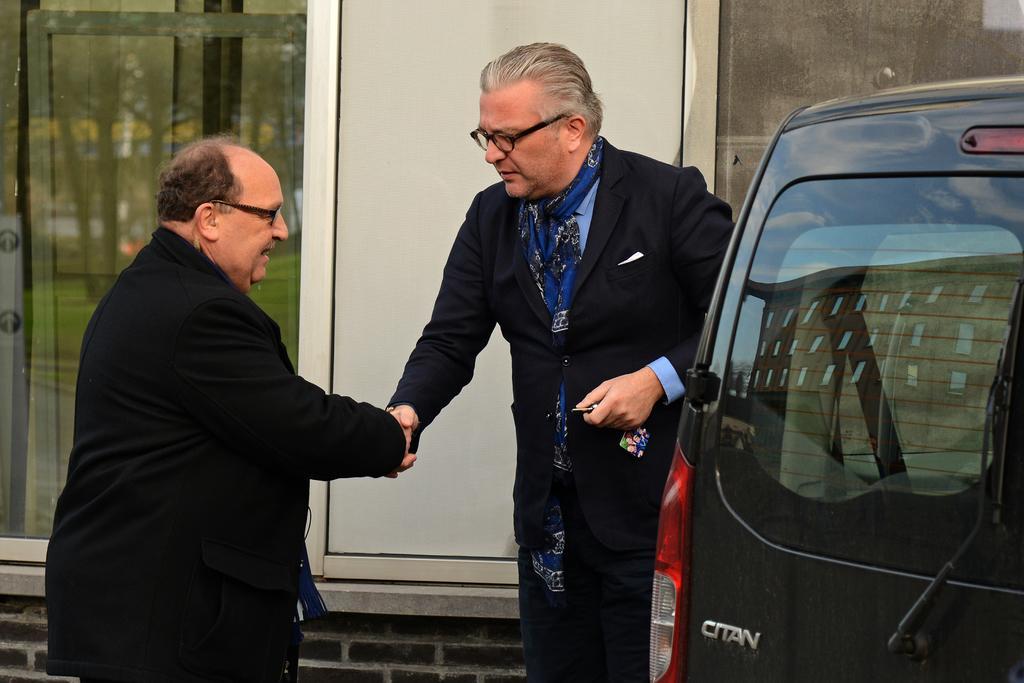Could you give a brief overview of what you see in this image? In this image we can see two people shaking their hands. We can also see a car beside them. On the backside we can see a wall and the windows. 